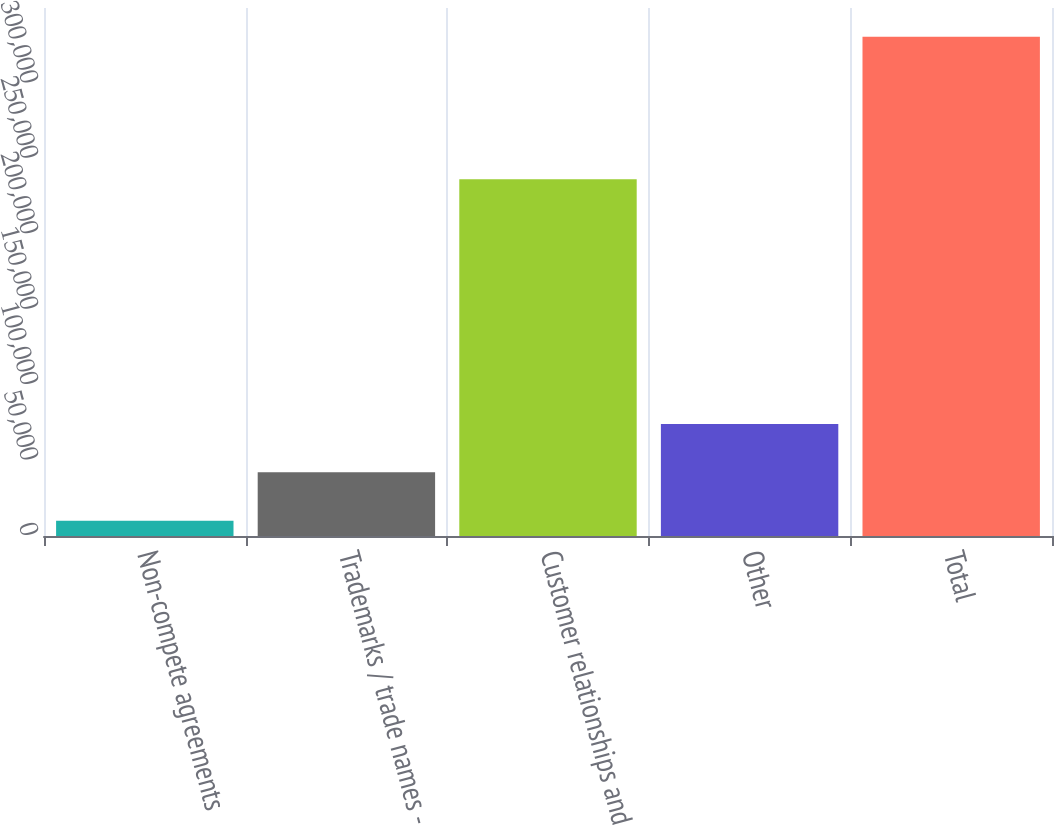Convert chart to OTSL. <chart><loc_0><loc_0><loc_500><loc_500><bar_chart><fcel>Non-compete agreements<fcel>Trademarks / trade names -<fcel>Customer relationships and<fcel>Other<fcel>Total<nl><fcel>10131<fcel>42214.8<fcel>236485<fcel>74298.6<fcel>330969<nl></chart> 